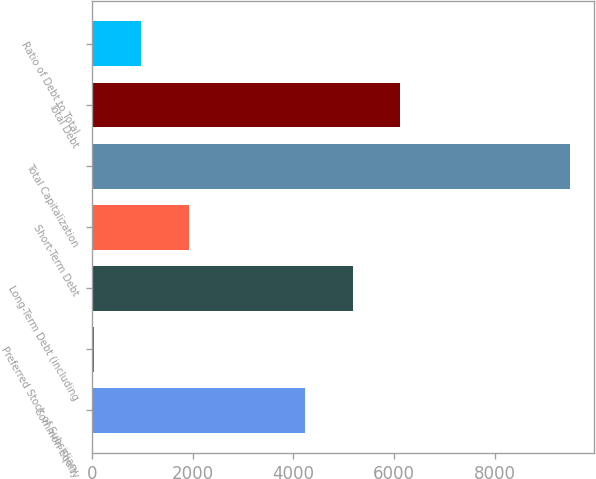Convert chart. <chart><loc_0><loc_0><loc_500><loc_500><bar_chart><fcel>Common Equity<fcel>Preferred Stock of Subsidiary<fcel>Long-Term Debt (including<fcel>Short-Term Debt<fcel>Total Capitalization<fcel>Total Debt<fcel>Ratio of Debt to Total<nl><fcel>4233<fcel>30.4<fcel>5180.58<fcel>1925.56<fcel>9506.2<fcel>6128.16<fcel>977.98<nl></chart> 